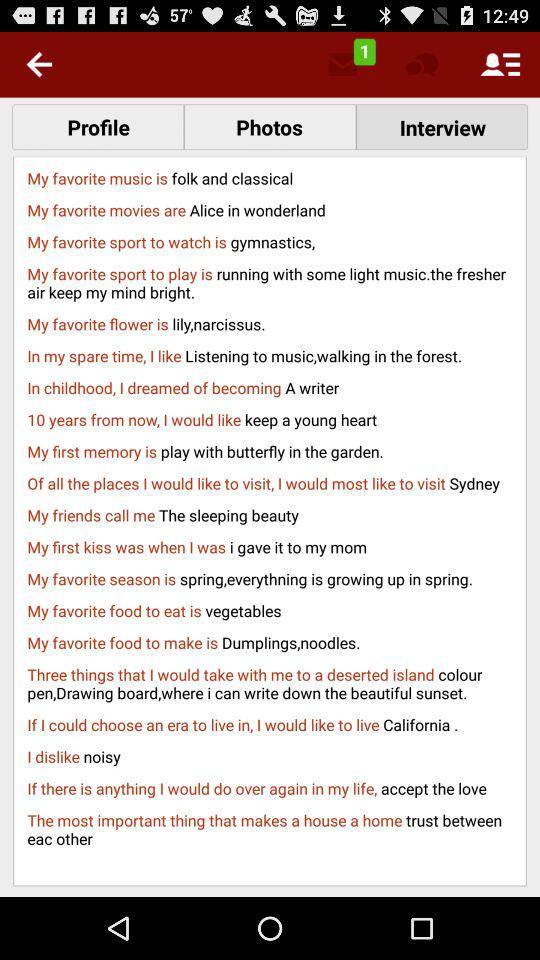Which food is my personal favorite to eat? Your personal favorite food to eat is vegetables. 